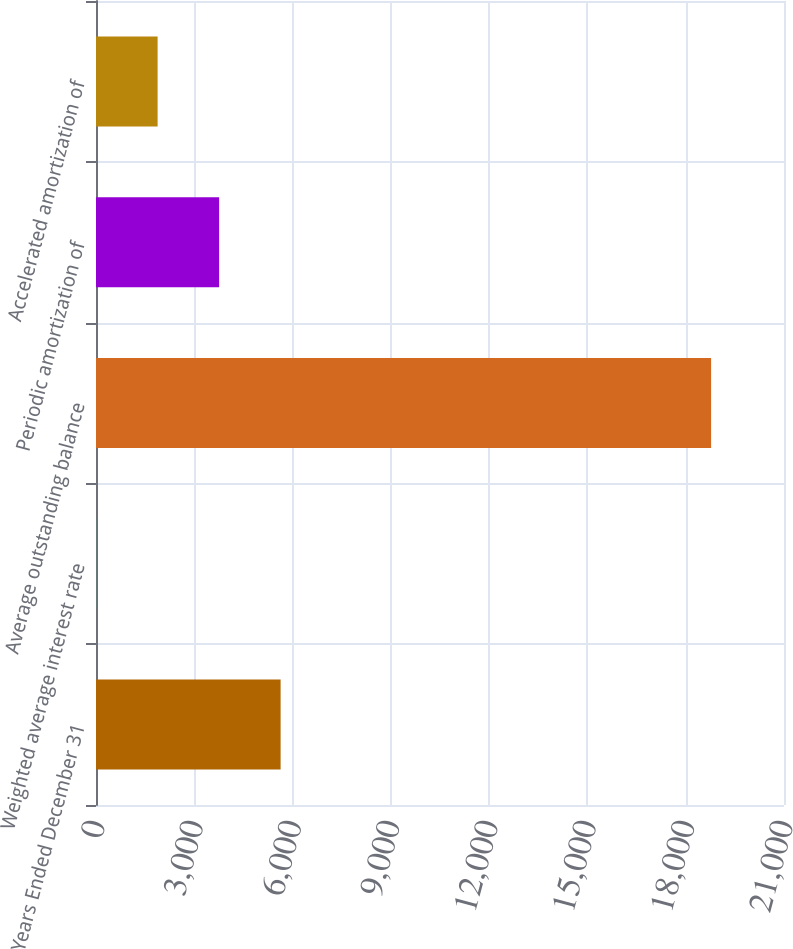<chart> <loc_0><loc_0><loc_500><loc_500><bar_chart><fcel>Years Ended December 31<fcel>Weighted average interest rate<fcel>Average outstanding balance<fcel>Periodic amortization of<fcel>Accelerated amortization of<nl><fcel>5634.81<fcel>3.3<fcel>18775<fcel>3757.64<fcel>1880.47<nl></chart> 